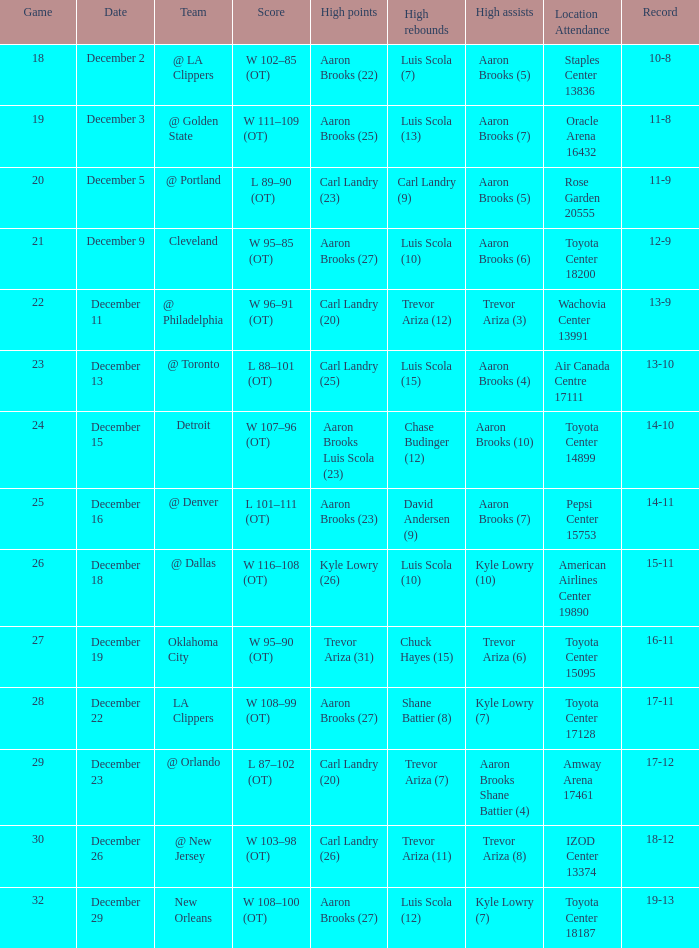What's the ultimate score of the contest where shane battier (8) achieved the peak rebounds? W 108–99 (OT). 